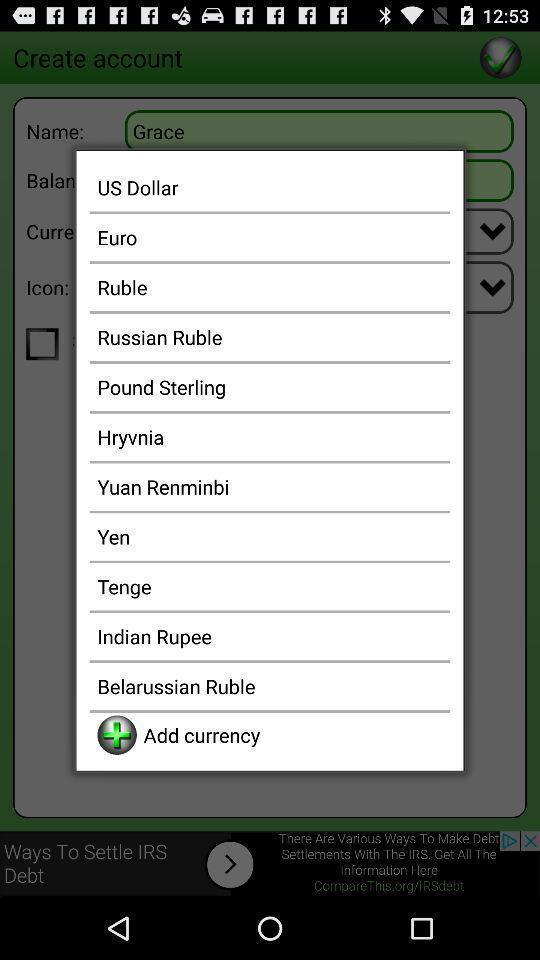Describe the visual elements of this screenshot. Various currency names displayed in a pop page. 